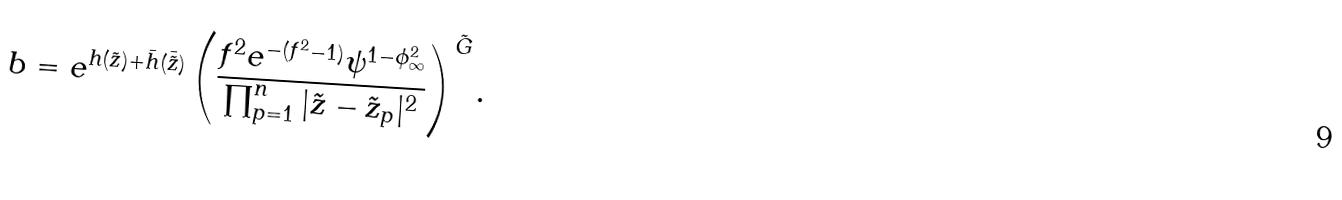Convert formula to latex. <formula><loc_0><loc_0><loc_500><loc_500>b = e ^ { h ( \tilde { z } ) + \bar { h } ( \bar { \tilde { z } } ) } \left ( \frac { f ^ { 2 } e ^ { - ( f ^ { 2 } - 1 ) } \psi ^ { 1 - \phi _ { \infty } ^ { 2 } } } { \prod _ { p = 1 } ^ { n } | \tilde { z } - \tilde { z } _ { p } | ^ { 2 } } \right ) ^ { \tilde { G } } .</formula> 